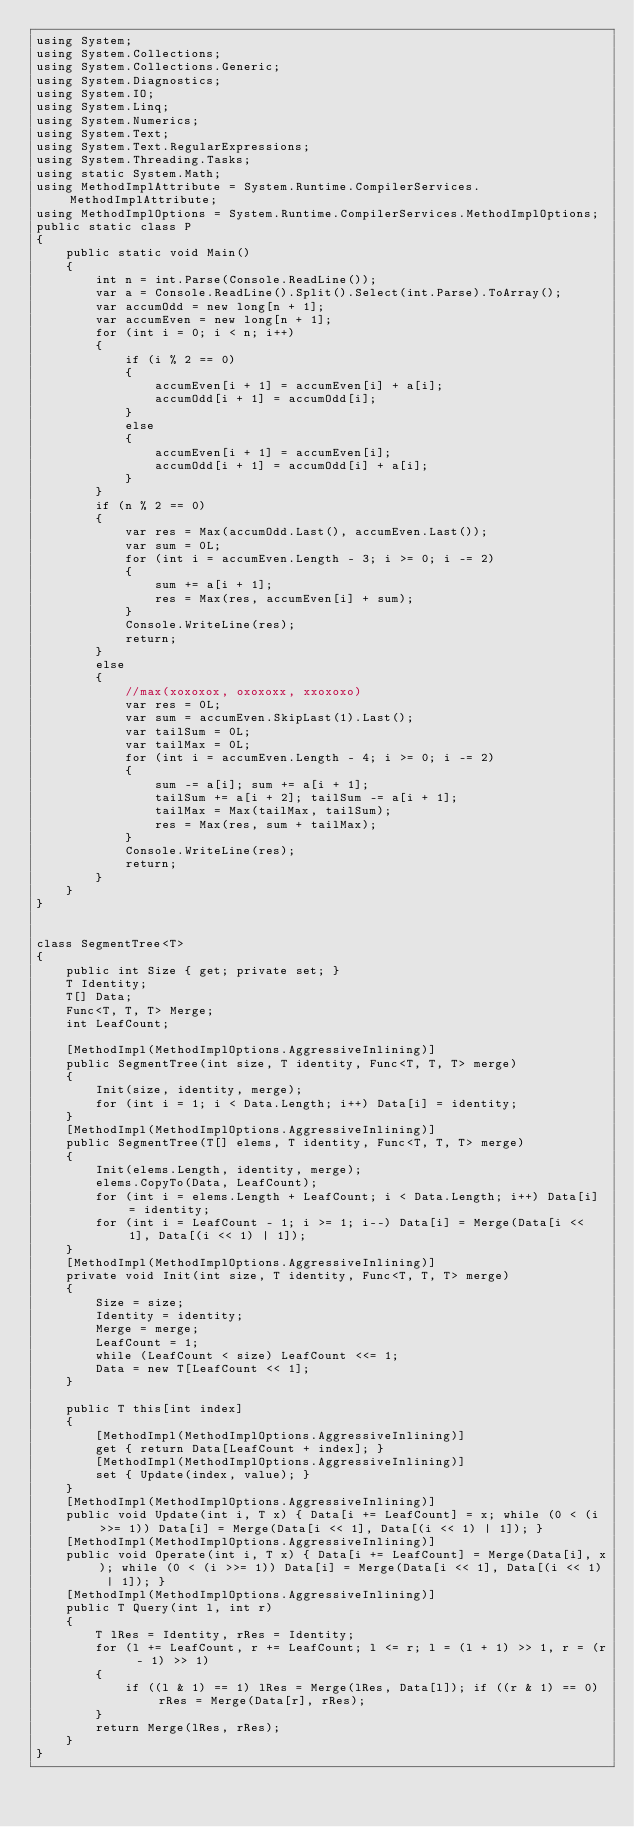<code> <loc_0><loc_0><loc_500><loc_500><_C#_>using System;
using System.Collections;
using System.Collections.Generic;
using System.Diagnostics;
using System.IO;
using System.Linq;
using System.Numerics;
using System.Text;
using System.Text.RegularExpressions;
using System.Threading.Tasks;
using static System.Math;
using MethodImplAttribute = System.Runtime.CompilerServices.MethodImplAttribute;
using MethodImplOptions = System.Runtime.CompilerServices.MethodImplOptions;
public static class P
{
    public static void Main()
    {
        int n = int.Parse(Console.ReadLine());
        var a = Console.ReadLine().Split().Select(int.Parse).ToArray();
        var accumOdd = new long[n + 1];
        var accumEven = new long[n + 1];
        for (int i = 0; i < n; i++)
        {
            if (i % 2 == 0)
            {
                accumEven[i + 1] = accumEven[i] + a[i];
                accumOdd[i + 1] = accumOdd[i];
            }
            else
            {
                accumEven[i + 1] = accumEven[i];
                accumOdd[i + 1] = accumOdd[i] + a[i];
            }
        }
        if (n % 2 == 0)
        {
            var res = Max(accumOdd.Last(), accumEven.Last());
            var sum = 0L;
            for (int i = accumEven.Length - 3; i >= 0; i -= 2)
            {
                sum += a[i + 1];
                res = Max(res, accumEven[i] + sum);
            }
            Console.WriteLine(res);
            return;
        }
        else
        {
            //max(xoxoxox, oxoxoxx, xxoxoxo)
            var res = 0L;
            var sum = accumEven.SkipLast(1).Last();
            var tailSum = 0L;
            var tailMax = 0L;
            for (int i = accumEven.Length - 4; i >= 0; i -= 2)
            {
                sum -= a[i]; sum += a[i + 1];
                tailSum += a[i + 2]; tailSum -= a[i + 1];
                tailMax = Max(tailMax, tailSum);
                res = Max(res, sum + tailMax);
            }
            Console.WriteLine(res);
            return;
        }
    }
}


class SegmentTree<T>
{
    public int Size { get; private set; }
    T Identity;
    T[] Data;
    Func<T, T, T> Merge;
    int LeafCount;

    [MethodImpl(MethodImplOptions.AggressiveInlining)]
    public SegmentTree(int size, T identity, Func<T, T, T> merge)
    {
        Init(size, identity, merge);
        for (int i = 1; i < Data.Length; i++) Data[i] = identity;
    }
    [MethodImpl(MethodImplOptions.AggressiveInlining)]
    public SegmentTree(T[] elems, T identity, Func<T, T, T> merge)
    {
        Init(elems.Length, identity, merge);
        elems.CopyTo(Data, LeafCount);
        for (int i = elems.Length + LeafCount; i < Data.Length; i++) Data[i] = identity;
        for (int i = LeafCount - 1; i >= 1; i--) Data[i] = Merge(Data[i << 1], Data[(i << 1) | 1]);
    }
    [MethodImpl(MethodImplOptions.AggressiveInlining)]
    private void Init(int size, T identity, Func<T, T, T> merge)
    {
        Size = size;
        Identity = identity;
        Merge = merge;
        LeafCount = 1;
        while (LeafCount < size) LeafCount <<= 1;
        Data = new T[LeafCount << 1];
    }

    public T this[int index]
    {
        [MethodImpl(MethodImplOptions.AggressiveInlining)]
        get { return Data[LeafCount + index]; }
        [MethodImpl(MethodImplOptions.AggressiveInlining)]
        set { Update(index, value); }
    }
    [MethodImpl(MethodImplOptions.AggressiveInlining)]
    public void Update(int i, T x) { Data[i += LeafCount] = x; while (0 < (i >>= 1)) Data[i] = Merge(Data[i << 1], Data[(i << 1) | 1]); }
    [MethodImpl(MethodImplOptions.AggressiveInlining)]
    public void Operate(int i, T x) { Data[i += LeafCount] = Merge(Data[i], x); while (0 < (i >>= 1)) Data[i] = Merge(Data[i << 1], Data[(i << 1) | 1]); }
    [MethodImpl(MethodImplOptions.AggressiveInlining)]
    public T Query(int l, int r)
    {
        T lRes = Identity, rRes = Identity;
        for (l += LeafCount, r += LeafCount; l <= r; l = (l + 1) >> 1, r = (r - 1) >> 1)
        {
            if ((l & 1) == 1) lRes = Merge(lRes, Data[l]); if ((r & 1) == 0) rRes = Merge(Data[r], rRes);
        }
        return Merge(lRes, rRes);
    }
}
</code> 